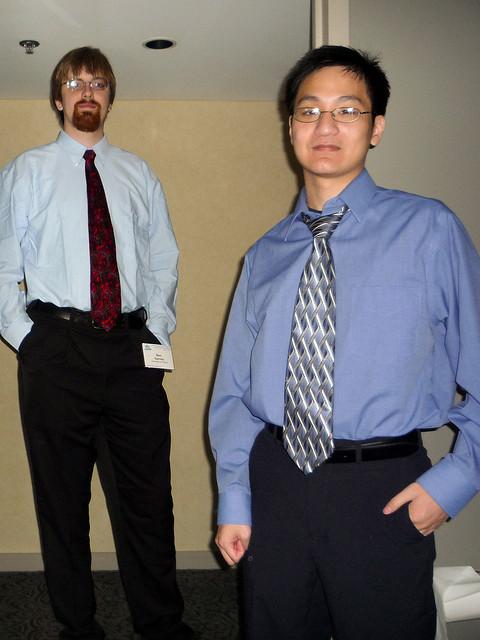Is the man wearing a shirt?
Give a very brief answer. Yes. Are all the men wearing black pants?
Give a very brief answer. Yes. Are all the men the same race?
Short answer required. No. Are they playing a video game?
Write a very short answer. No. What type of shirt is the guy standing up wearing?
Short answer required. Blue. How many people are in the photo?
Be succinct. 2. Does he have black hair?
Short answer required. Yes. Are they a couple?
Concise answer only. No. What does the person on the left have around his neck?
Short answer required. Tie. What color is the tie of the man on the left?
Give a very brief answer. Red and black. Is the boy in blue doing a trick?
Write a very short answer. No. How many people are in photo?
Be succinct. 2. What matching objects do the men wear?
Concise answer only. Ties. What color is the man's necktie?
Be succinct. Silver. Is the tie tied?
Give a very brief answer. Yes. What style facial hair is the man in the white shirt wearing?
Concise answer only. Goatee. 